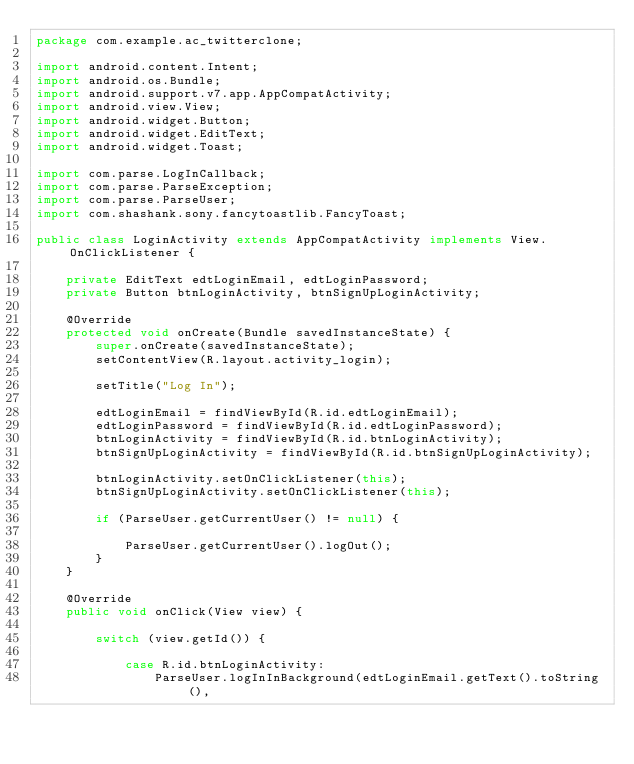Convert code to text. <code><loc_0><loc_0><loc_500><loc_500><_Java_>package com.example.ac_twitterclone;

import android.content.Intent;
import android.os.Bundle;
import android.support.v7.app.AppCompatActivity;
import android.view.View;
import android.widget.Button;
import android.widget.EditText;
import android.widget.Toast;

import com.parse.LogInCallback;
import com.parse.ParseException;
import com.parse.ParseUser;
import com.shashank.sony.fancytoastlib.FancyToast;

public class LoginActivity extends AppCompatActivity implements View.OnClickListener {

    private EditText edtLoginEmail, edtLoginPassword;
    private Button btnLoginActivity, btnSignUpLoginActivity;

    @Override
    protected void onCreate(Bundle savedInstanceState) {
        super.onCreate(savedInstanceState);
        setContentView(R.layout.activity_login);

        setTitle("Log In");

        edtLoginEmail = findViewById(R.id.edtLoginEmail);
        edtLoginPassword = findViewById(R.id.edtLoginPassword);
        btnLoginActivity = findViewById(R.id.btnLoginActivity);
        btnSignUpLoginActivity = findViewById(R.id.btnSignUpLoginActivity);

        btnLoginActivity.setOnClickListener(this);
        btnSignUpLoginActivity.setOnClickListener(this);

        if (ParseUser.getCurrentUser() != null) {

            ParseUser.getCurrentUser().logOut();
        }
    }

    @Override
    public void onClick(View view) {

        switch (view.getId()) {

            case R.id.btnLoginActivity:
                ParseUser.logInInBackground(edtLoginEmail.getText().toString(),</code> 